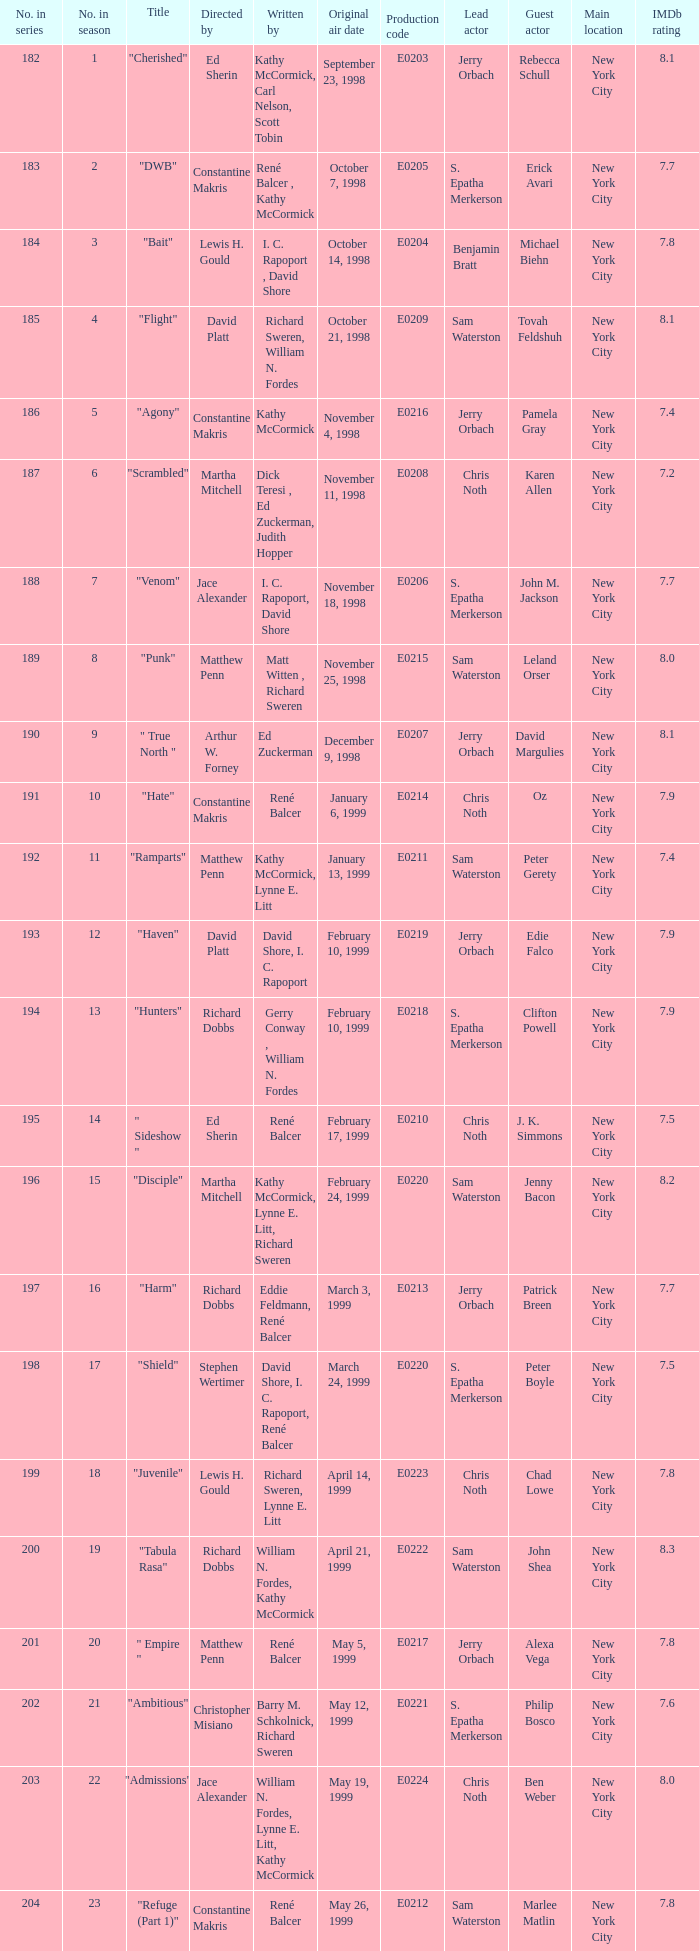The episode with the production code E0208 is directed by who? Martha Mitchell. 